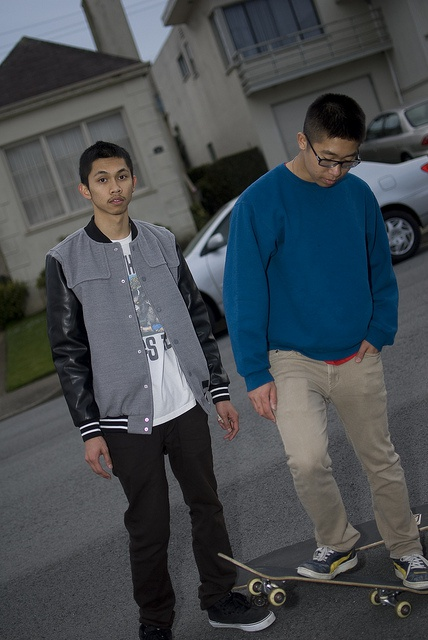Describe the objects in this image and their specific colors. I can see people in darkgray, darkblue, gray, and black tones, people in darkgray, black, and gray tones, car in darkgray, black, and gray tones, skateboard in darkgray, black, and gray tones, and car in darkgray, black, gray, and purple tones in this image. 